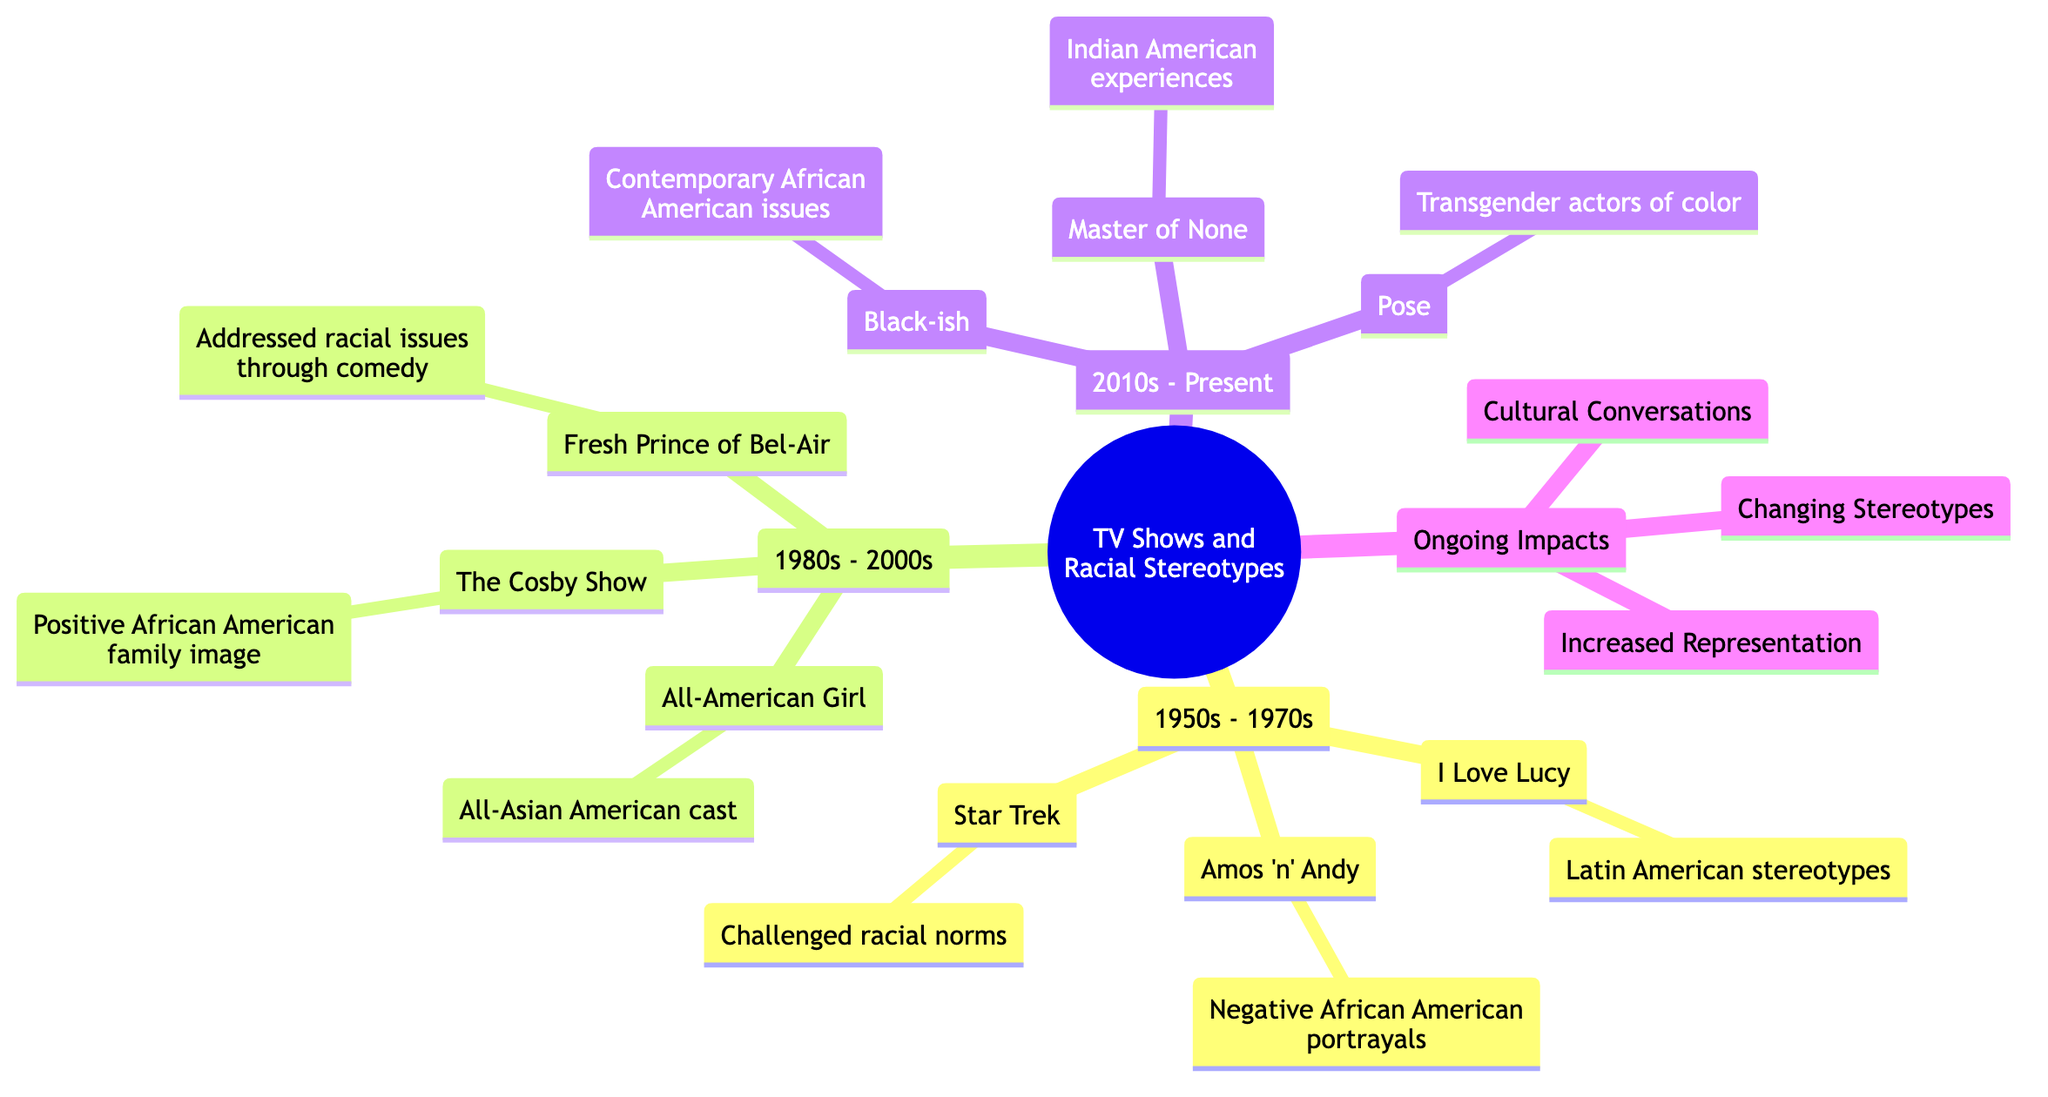What is the influence of "I Love Lucy"? The diagram states that "I Love Lucy" introduced Latin American characters to mainstream TV, often depicting them with stereotypical traits.
Answer: Introduced Latin American characters How many pioneering TV shows are listed from the 1980s to 2000s? The diagram lists three pioneering TV shows in the 1980s to 2000s category: "The Cosby Show," "Fresh Prince of Bel-Air," and "All-American Girl."
Answer: 3 What racial issue does "Black-ish" address? According to the diagram, "Black-ish" explores contemporary racial issues faced by African American families.
Answer: Contemporary racial issues Which show was one of the first sitcoms to feature an all-Asian American cast? The diagram highlights "All-American Girl" as one of the first sitcoms featuring an all-Asian American cast.
Answer: All-American Girl What is a key impact of television shows listed under "Ongoing Impacts"? The diagram mentions "Increased Representation" as a key impact of television shows today, indicating greater visibility of diverse racial groups.
Answer: Increased Representation How does "Star Trek" contribute to the discussion on racial stereotypes? "Star Trek" is noted for featuring one of the first interracial kisses on American television, challenging prevalent racial norms and contributing to discussions on racial stereotypes.
Answer: Challenging racial norms What is the overall theme of the shows listed in the "2010s - Present" section? The shows listed in this section address contemporary issues and reflect more complex narratives about racial identities and experiences, focusing on diverse perspectives.
Answer: Contemporary racial issues How do modern shows challenge historical racial stereotypes? According to the diagram, modern shows provide more complex and multi-dimensional characters, which challenge the historical racial stereotypes depicted in earlier shows.
Answer: Changing Stereotypes What genre of television does "Pose" represent? "Pose" features one of the largest casts of transgender actors of color, representing a significant genre in terms of diversity in casting and focus.
Answer: Transgender actors of color 